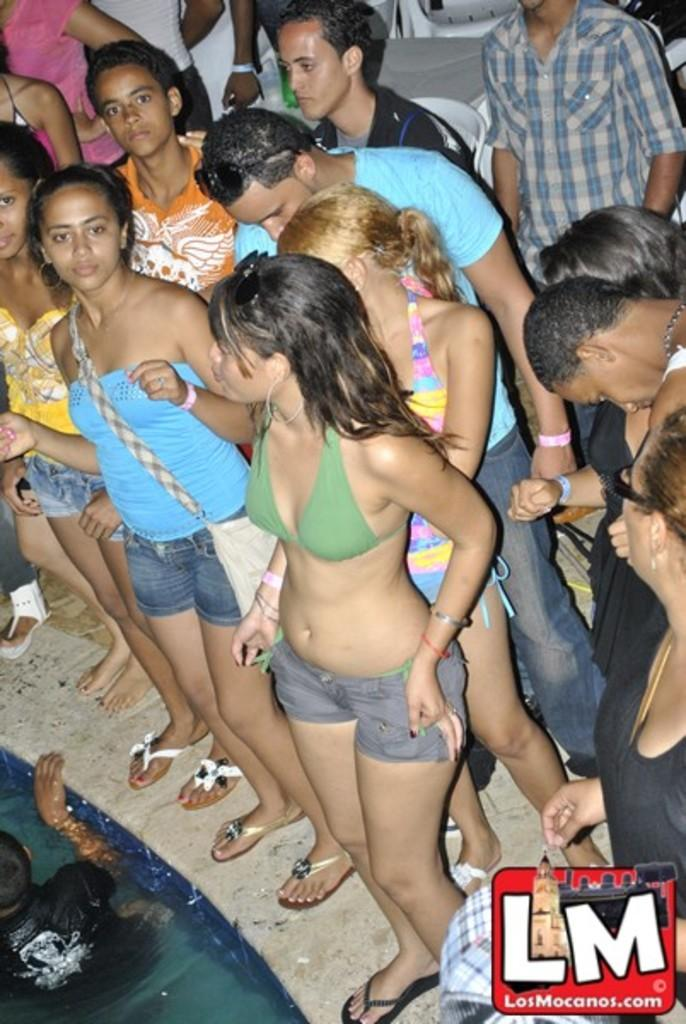What is the main subject of the image? The main subject of the image is a crowd of people. Where are the people standing in the image? The people are standing on the floor in the image. Can you describe the person in the water in the image? There is a person in the water in the bottom left of the image. What type of water feature is present in the image? The water appears to be in a pool. What is located in the bottom right of the image? There is a logo in the bottom right of the image. What type of nerve can be seen stimulating the muscles of the person in the water? There are no visible nerves or muscles in the image, as it only shows a person in the water and a crowd of people. 